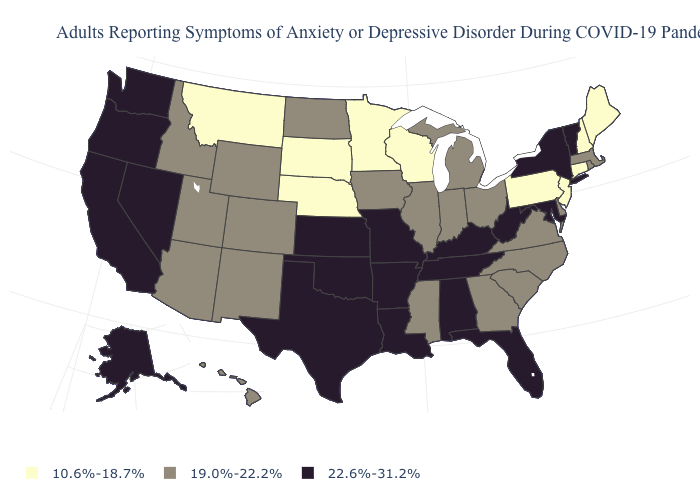Among the states that border Illinois , does Kentucky have the highest value?
Give a very brief answer. Yes. Among the states that border Oregon , which have the lowest value?
Be succinct. Idaho. Does Rhode Island have a lower value than Arkansas?
Quick response, please. Yes. Is the legend a continuous bar?
Write a very short answer. No. Name the states that have a value in the range 10.6%-18.7%?
Write a very short answer. Connecticut, Maine, Minnesota, Montana, Nebraska, New Hampshire, New Jersey, Pennsylvania, South Dakota, Wisconsin. Does the map have missing data?
Answer briefly. No. What is the value of Indiana?
Give a very brief answer. 19.0%-22.2%. Among the states that border Arkansas , does Oklahoma have the highest value?
Short answer required. Yes. What is the highest value in the South ?
Quick response, please. 22.6%-31.2%. Name the states that have a value in the range 22.6%-31.2%?
Short answer required. Alabama, Alaska, Arkansas, California, Florida, Kansas, Kentucky, Louisiana, Maryland, Missouri, Nevada, New York, Oklahoma, Oregon, Tennessee, Texas, Vermont, Washington, West Virginia. What is the lowest value in the MidWest?
Concise answer only. 10.6%-18.7%. What is the value of North Carolina?
Write a very short answer. 19.0%-22.2%. Does Iowa have the same value as Illinois?
Short answer required. Yes. What is the value of Louisiana?
Quick response, please. 22.6%-31.2%. 